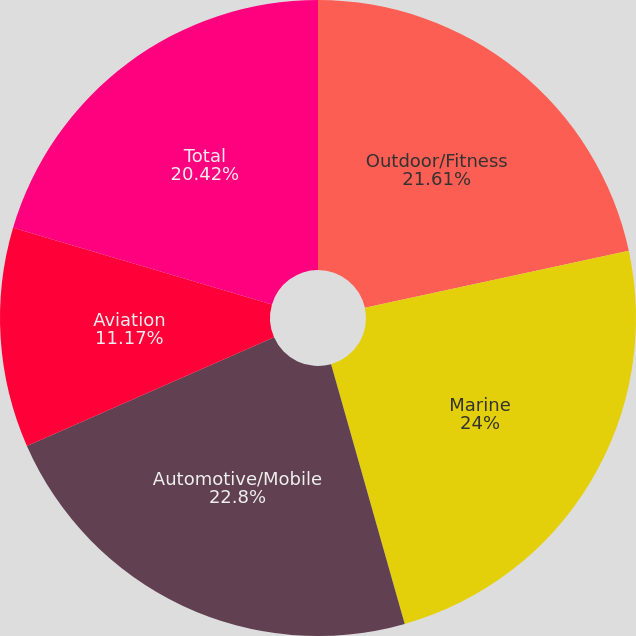<chart> <loc_0><loc_0><loc_500><loc_500><pie_chart><fcel>Outdoor/Fitness<fcel>Marine<fcel>Automotive/Mobile<fcel>Aviation<fcel>Total<nl><fcel>21.61%<fcel>23.99%<fcel>22.8%<fcel>11.17%<fcel>20.42%<nl></chart> 